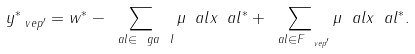Convert formula to latex. <formula><loc_0><loc_0><loc_500><loc_500>y _ { \ v e p ^ { \prime } } ^ { * } = w ^ { * } - \sum _ { \ a l \in \ g a \ I } \mu _ { \ } a l x _ { \ } a l ^ { * } + \sum _ { \ a l \in F _ { \ v e p ^ { \prime } } } \mu _ { \ } a l x _ { \ } a l ^ { * } .</formula> 